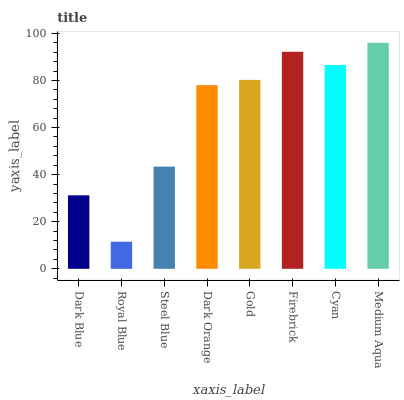Is Royal Blue the minimum?
Answer yes or no. Yes. Is Medium Aqua the maximum?
Answer yes or no. Yes. Is Steel Blue the minimum?
Answer yes or no. No. Is Steel Blue the maximum?
Answer yes or no. No. Is Steel Blue greater than Royal Blue?
Answer yes or no. Yes. Is Royal Blue less than Steel Blue?
Answer yes or no. Yes. Is Royal Blue greater than Steel Blue?
Answer yes or no. No. Is Steel Blue less than Royal Blue?
Answer yes or no. No. Is Gold the high median?
Answer yes or no. Yes. Is Dark Orange the low median?
Answer yes or no. Yes. Is Firebrick the high median?
Answer yes or no. No. Is Royal Blue the low median?
Answer yes or no. No. 